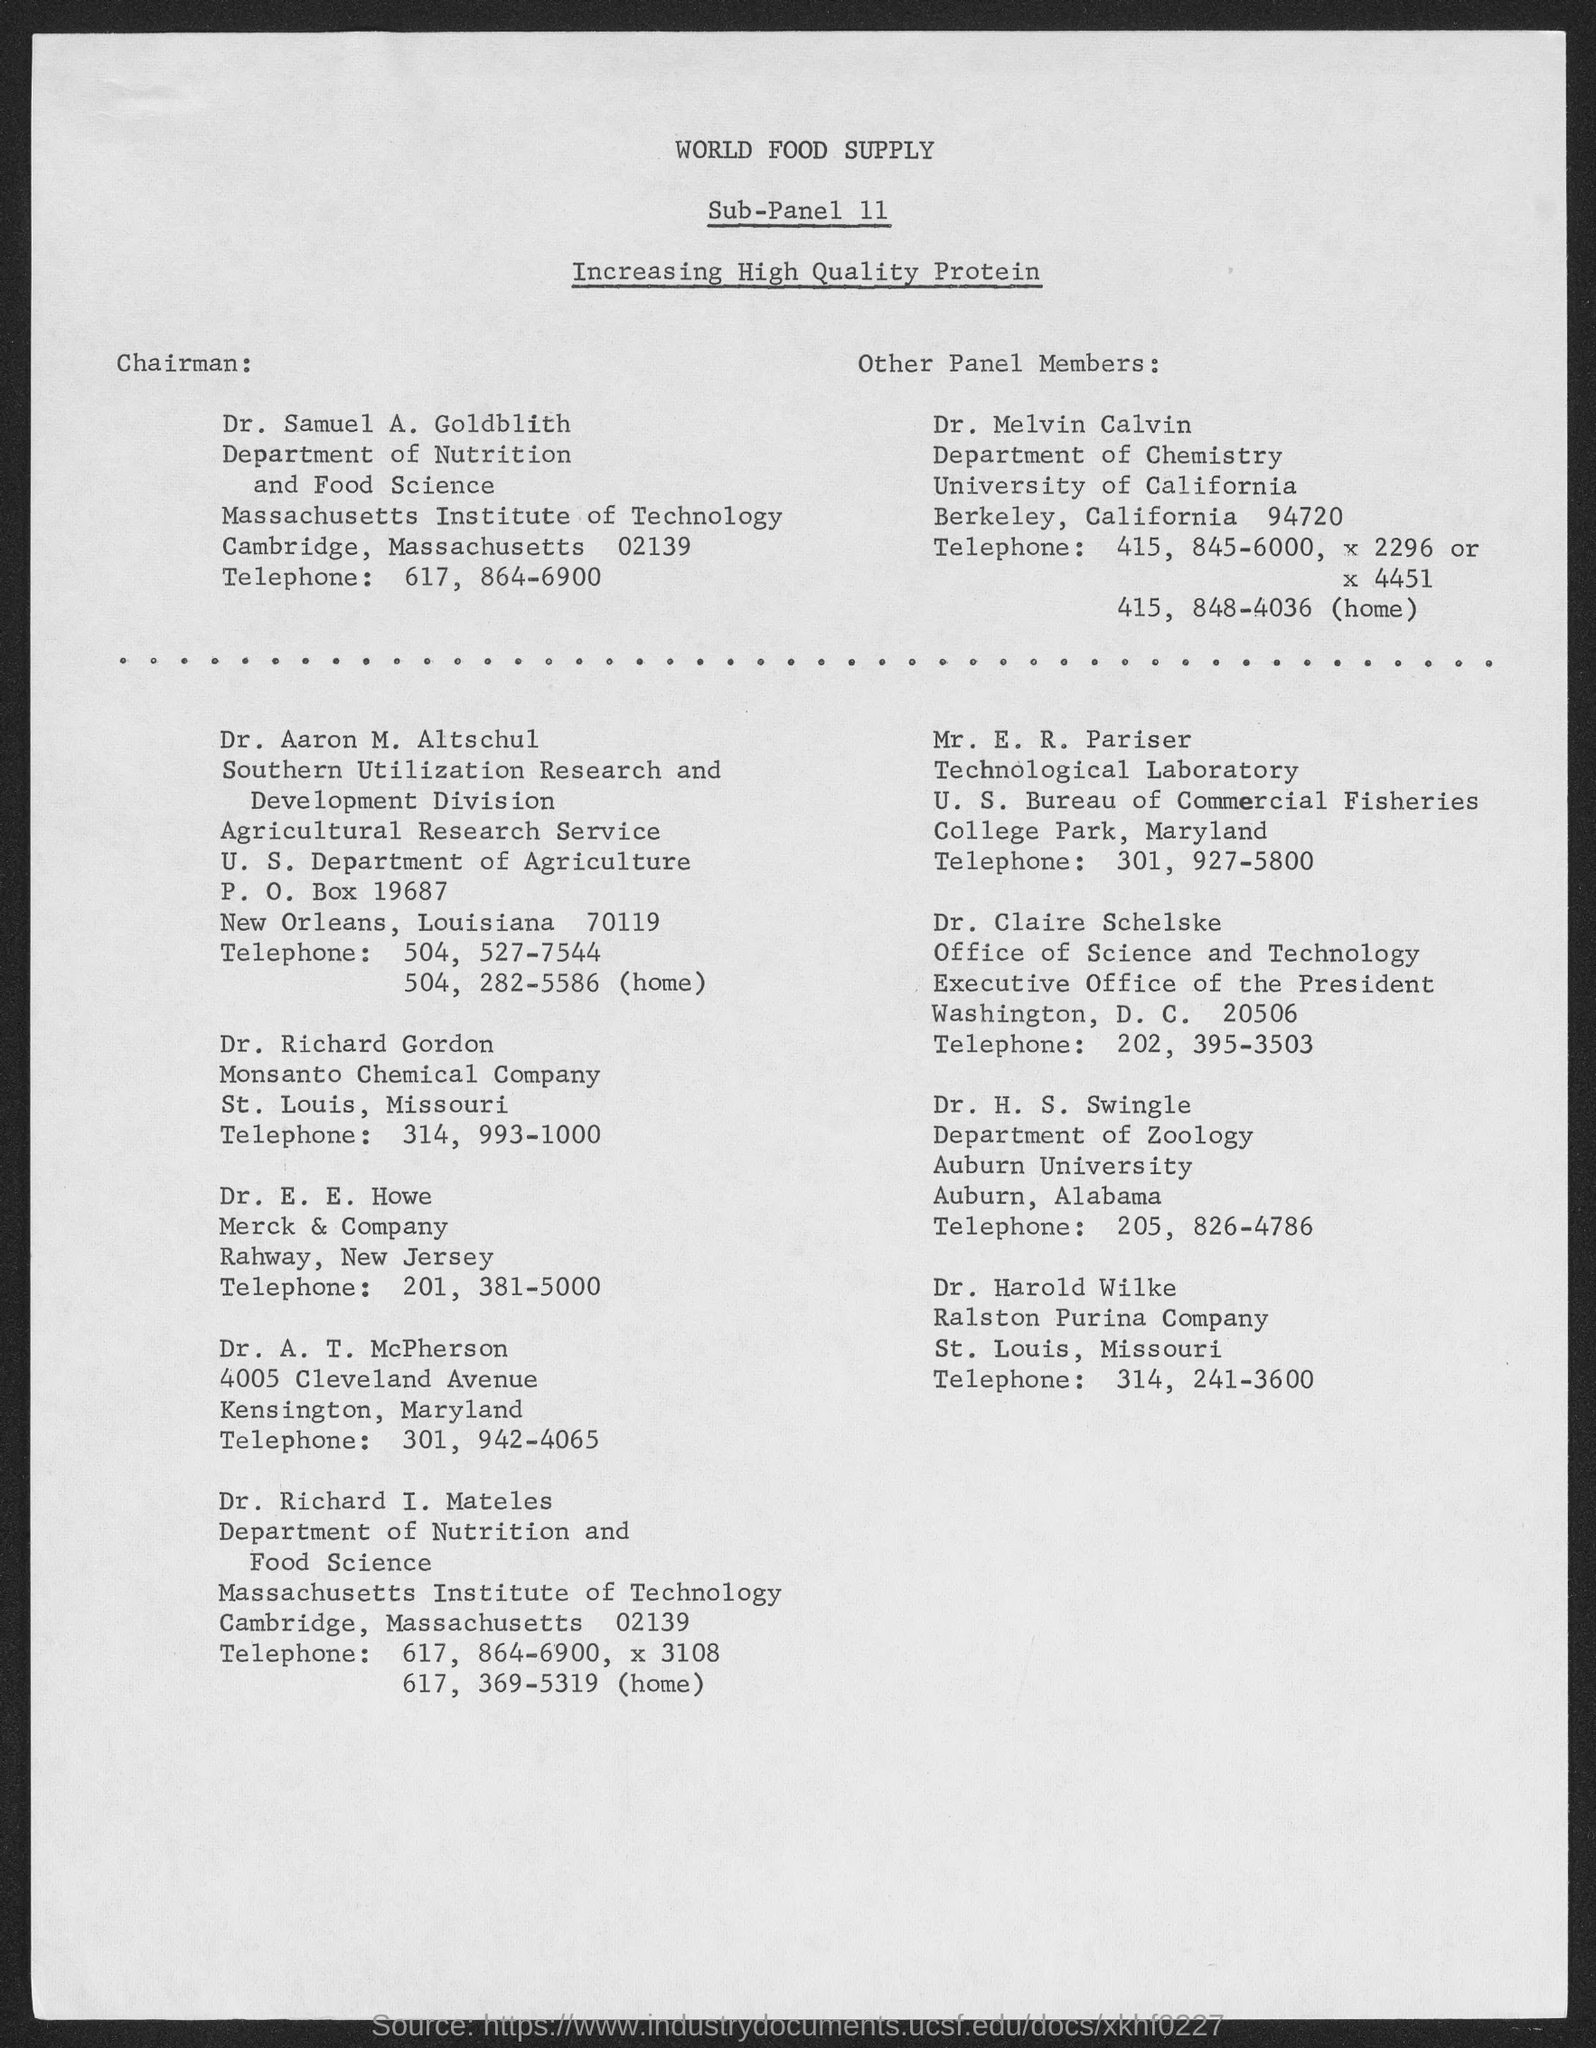Outline some significant characteristics in this image. The Chairman of Sub-Panel 11 is Dr. Samuel A. Goldblith. The document provides the telephone number of Dr. Samuel A. Goldblith as 617-864-6900. 